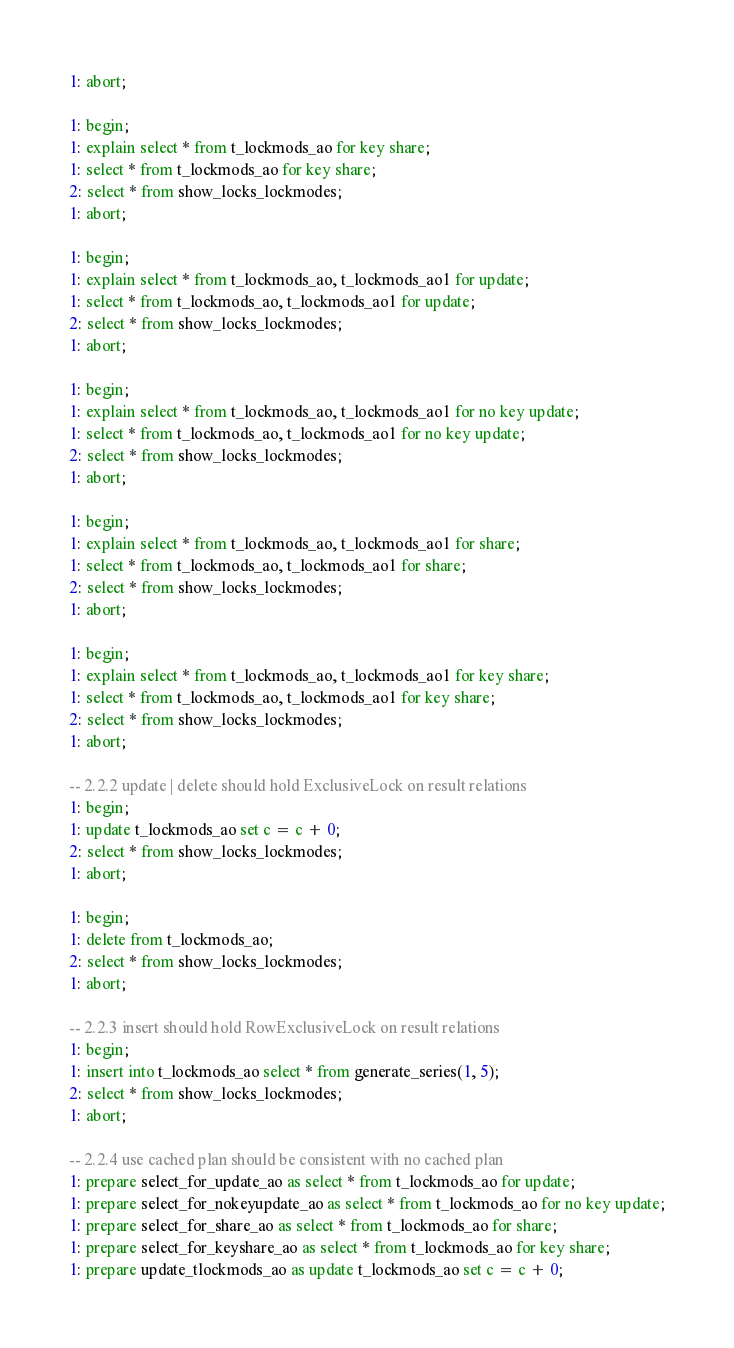Convert code to text. <code><loc_0><loc_0><loc_500><loc_500><_SQL_>1: abort;

1: begin;
1: explain select * from t_lockmods_ao for key share;
1: select * from t_lockmods_ao for key share;
2: select * from show_locks_lockmodes;
1: abort;

1: begin;
1: explain select * from t_lockmods_ao, t_lockmods_ao1 for update;
1: select * from t_lockmods_ao, t_lockmods_ao1 for update;
2: select * from show_locks_lockmodes;
1: abort;

1: begin;
1: explain select * from t_lockmods_ao, t_lockmods_ao1 for no key update;
1: select * from t_lockmods_ao, t_lockmods_ao1 for no key update;
2: select * from show_locks_lockmodes;
1: abort;

1: begin;
1: explain select * from t_lockmods_ao, t_lockmods_ao1 for share;
1: select * from t_lockmods_ao, t_lockmods_ao1 for share;
2: select * from show_locks_lockmodes;
1: abort;

1: begin;
1: explain select * from t_lockmods_ao, t_lockmods_ao1 for key share;
1: select * from t_lockmods_ao, t_lockmods_ao1 for key share;
2: select * from show_locks_lockmodes;
1: abort;

-- 2.2.2 update | delete should hold ExclusiveLock on result relations
1: begin;
1: update t_lockmods_ao set c = c + 0;
2: select * from show_locks_lockmodes;
1: abort;

1: begin;
1: delete from t_lockmods_ao;
2: select * from show_locks_lockmodes;
1: abort;

-- 2.2.3 insert should hold RowExclusiveLock on result relations
1: begin;
1: insert into t_lockmods_ao select * from generate_series(1, 5);
2: select * from show_locks_lockmodes;
1: abort;

-- 2.2.4 use cached plan should be consistent with no cached plan
1: prepare select_for_update_ao as select * from t_lockmods_ao for update;
1: prepare select_for_nokeyupdate_ao as select * from t_lockmods_ao for no key update;
1: prepare select_for_share_ao as select * from t_lockmods_ao for share;
1: prepare select_for_keyshare_ao as select * from t_lockmods_ao for key share;
1: prepare update_tlockmods_ao as update t_lockmods_ao set c = c + 0;</code> 